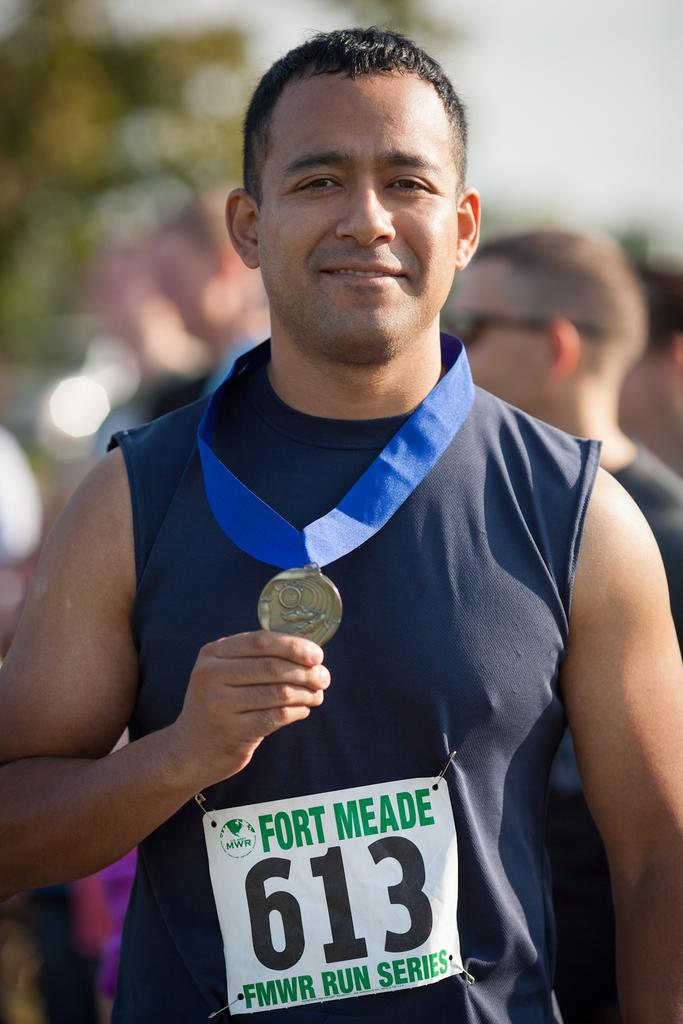Provide a one-sentence caption for the provided image. Runner number 613 in the Fort Meade run series poses with his medal. 